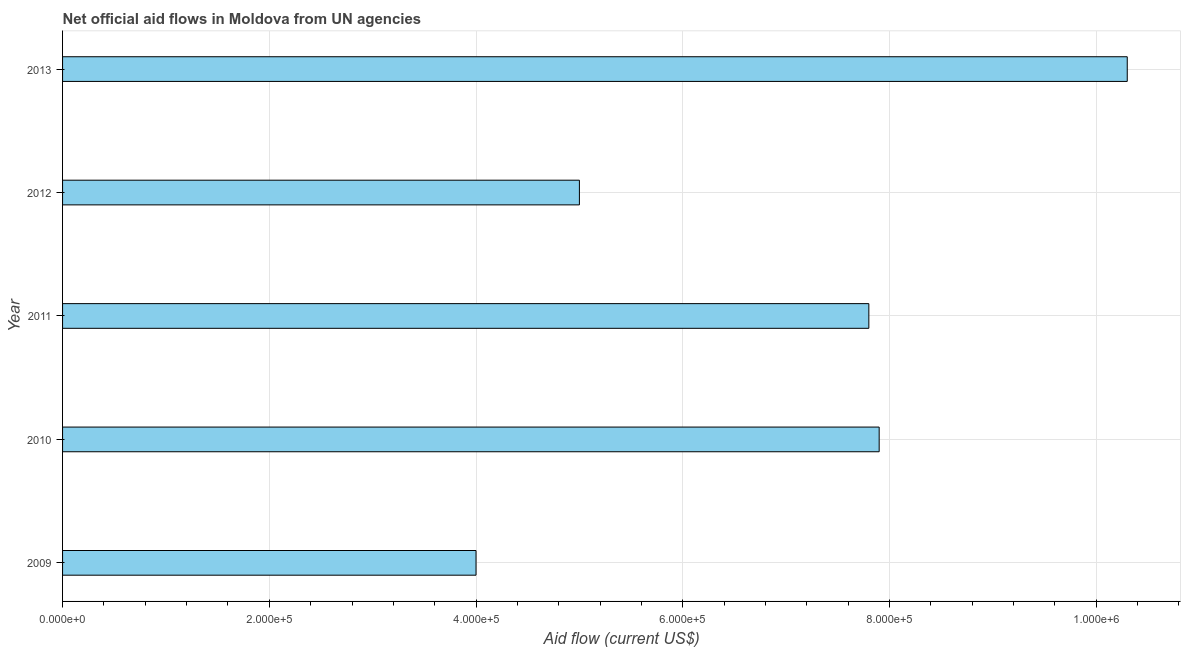Does the graph contain any zero values?
Give a very brief answer. No. What is the title of the graph?
Your answer should be very brief. Net official aid flows in Moldova from UN agencies. What is the net official flows from un agencies in 2013?
Your response must be concise. 1.03e+06. Across all years, what is the maximum net official flows from un agencies?
Ensure brevity in your answer.  1.03e+06. What is the sum of the net official flows from un agencies?
Give a very brief answer. 3.50e+06. What is the difference between the net official flows from un agencies in 2011 and 2012?
Your answer should be very brief. 2.80e+05. What is the median net official flows from un agencies?
Offer a terse response. 7.80e+05. Do a majority of the years between 2011 and 2013 (inclusive) have net official flows from un agencies greater than 880000 US$?
Offer a terse response. No. What is the ratio of the net official flows from un agencies in 2011 to that in 2012?
Ensure brevity in your answer.  1.56. Is the net official flows from un agencies in 2010 less than that in 2011?
Provide a succinct answer. No. Is the difference between the net official flows from un agencies in 2010 and 2011 greater than the difference between any two years?
Make the answer very short. No. What is the difference between the highest and the second highest net official flows from un agencies?
Your answer should be compact. 2.40e+05. Is the sum of the net official flows from un agencies in 2012 and 2013 greater than the maximum net official flows from un agencies across all years?
Give a very brief answer. Yes. What is the difference between the highest and the lowest net official flows from un agencies?
Give a very brief answer. 6.30e+05. Are all the bars in the graph horizontal?
Offer a terse response. Yes. How many years are there in the graph?
Your answer should be compact. 5. Are the values on the major ticks of X-axis written in scientific E-notation?
Ensure brevity in your answer.  Yes. What is the Aid flow (current US$) in 2010?
Keep it short and to the point. 7.90e+05. What is the Aid flow (current US$) in 2011?
Give a very brief answer. 7.80e+05. What is the Aid flow (current US$) in 2012?
Make the answer very short. 5.00e+05. What is the Aid flow (current US$) in 2013?
Give a very brief answer. 1.03e+06. What is the difference between the Aid flow (current US$) in 2009 and 2010?
Your response must be concise. -3.90e+05. What is the difference between the Aid flow (current US$) in 2009 and 2011?
Your answer should be compact. -3.80e+05. What is the difference between the Aid flow (current US$) in 2009 and 2013?
Make the answer very short. -6.30e+05. What is the difference between the Aid flow (current US$) in 2010 and 2013?
Offer a terse response. -2.40e+05. What is the difference between the Aid flow (current US$) in 2011 and 2012?
Provide a short and direct response. 2.80e+05. What is the difference between the Aid flow (current US$) in 2012 and 2013?
Offer a terse response. -5.30e+05. What is the ratio of the Aid flow (current US$) in 2009 to that in 2010?
Your response must be concise. 0.51. What is the ratio of the Aid flow (current US$) in 2009 to that in 2011?
Your response must be concise. 0.51. What is the ratio of the Aid flow (current US$) in 2009 to that in 2013?
Your answer should be compact. 0.39. What is the ratio of the Aid flow (current US$) in 2010 to that in 2011?
Make the answer very short. 1.01. What is the ratio of the Aid flow (current US$) in 2010 to that in 2012?
Ensure brevity in your answer.  1.58. What is the ratio of the Aid flow (current US$) in 2010 to that in 2013?
Your answer should be very brief. 0.77. What is the ratio of the Aid flow (current US$) in 2011 to that in 2012?
Ensure brevity in your answer.  1.56. What is the ratio of the Aid flow (current US$) in 2011 to that in 2013?
Ensure brevity in your answer.  0.76. What is the ratio of the Aid flow (current US$) in 2012 to that in 2013?
Your answer should be very brief. 0.48. 